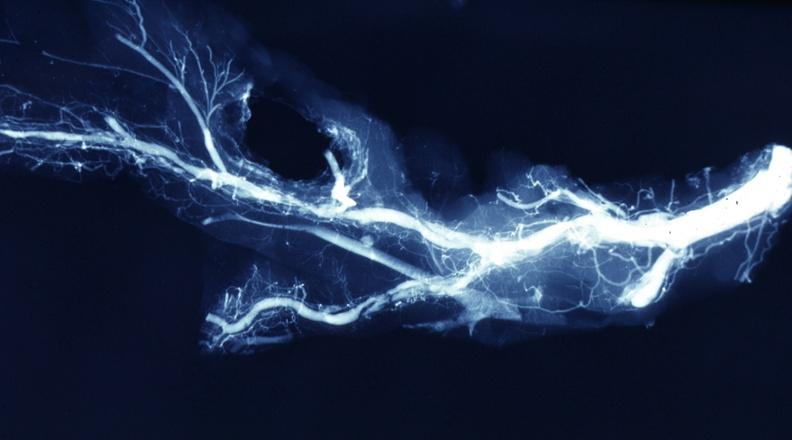s all the fat necrosis present?
Answer the question using a single word or phrase. No 